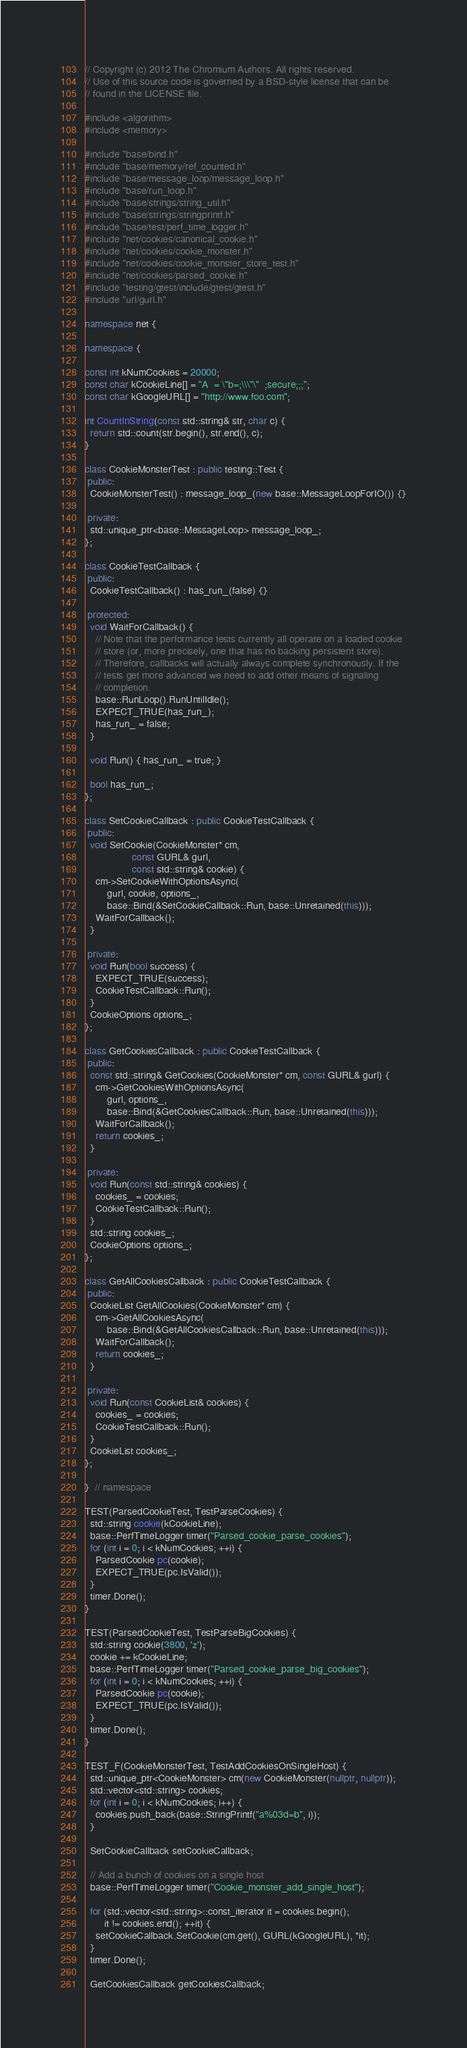Convert code to text. <code><loc_0><loc_0><loc_500><loc_500><_C++_>// Copyright (c) 2012 The Chromium Authors. All rights reserved.
// Use of this source code is governed by a BSD-style license that can be
// found in the LICENSE file.

#include <algorithm>
#include <memory>

#include "base/bind.h"
#include "base/memory/ref_counted.h"
#include "base/message_loop/message_loop.h"
#include "base/run_loop.h"
#include "base/strings/string_util.h"
#include "base/strings/stringprintf.h"
#include "base/test/perf_time_logger.h"
#include "net/cookies/canonical_cookie.h"
#include "net/cookies/cookie_monster.h"
#include "net/cookies/cookie_monster_store_test.h"
#include "net/cookies/parsed_cookie.h"
#include "testing/gtest/include/gtest/gtest.h"
#include "url/gurl.h"

namespace net {

namespace {

const int kNumCookies = 20000;
const char kCookieLine[] = "A  = \"b=;\\\"\"  ;secure;;;";
const char kGoogleURL[] = "http://www.foo.com";

int CountInString(const std::string& str, char c) {
  return std::count(str.begin(), str.end(), c);
}

class CookieMonsterTest : public testing::Test {
 public:
  CookieMonsterTest() : message_loop_(new base::MessageLoopForIO()) {}

 private:
  std::unique_ptr<base::MessageLoop> message_loop_;
};

class CookieTestCallback {
 public:
  CookieTestCallback() : has_run_(false) {}

 protected:
  void WaitForCallback() {
    // Note that the performance tests currently all operate on a loaded cookie
    // store (or, more precisely, one that has no backing persistent store).
    // Therefore, callbacks will actually always complete synchronously. If the
    // tests get more advanced we need to add other means of signaling
    // completion.
    base::RunLoop().RunUntilIdle();
    EXPECT_TRUE(has_run_);
    has_run_ = false;
  }

  void Run() { has_run_ = true; }

  bool has_run_;
};

class SetCookieCallback : public CookieTestCallback {
 public:
  void SetCookie(CookieMonster* cm,
                 const GURL& gurl,
                 const std::string& cookie) {
    cm->SetCookieWithOptionsAsync(
        gurl, cookie, options_,
        base::Bind(&SetCookieCallback::Run, base::Unretained(this)));
    WaitForCallback();
  }

 private:
  void Run(bool success) {
    EXPECT_TRUE(success);
    CookieTestCallback::Run();
  }
  CookieOptions options_;
};

class GetCookiesCallback : public CookieTestCallback {
 public:
  const std::string& GetCookies(CookieMonster* cm, const GURL& gurl) {
    cm->GetCookiesWithOptionsAsync(
        gurl, options_,
        base::Bind(&GetCookiesCallback::Run, base::Unretained(this)));
    WaitForCallback();
    return cookies_;
  }

 private:
  void Run(const std::string& cookies) {
    cookies_ = cookies;
    CookieTestCallback::Run();
  }
  std::string cookies_;
  CookieOptions options_;
};

class GetAllCookiesCallback : public CookieTestCallback {
 public:
  CookieList GetAllCookies(CookieMonster* cm) {
    cm->GetAllCookiesAsync(
        base::Bind(&GetAllCookiesCallback::Run, base::Unretained(this)));
    WaitForCallback();
    return cookies_;
  }

 private:
  void Run(const CookieList& cookies) {
    cookies_ = cookies;
    CookieTestCallback::Run();
  }
  CookieList cookies_;
};

}  // namespace

TEST(ParsedCookieTest, TestParseCookies) {
  std::string cookie(kCookieLine);
  base::PerfTimeLogger timer("Parsed_cookie_parse_cookies");
  for (int i = 0; i < kNumCookies; ++i) {
    ParsedCookie pc(cookie);
    EXPECT_TRUE(pc.IsValid());
  }
  timer.Done();
}

TEST(ParsedCookieTest, TestParseBigCookies) {
  std::string cookie(3800, 'z');
  cookie += kCookieLine;
  base::PerfTimeLogger timer("Parsed_cookie_parse_big_cookies");
  for (int i = 0; i < kNumCookies; ++i) {
    ParsedCookie pc(cookie);
    EXPECT_TRUE(pc.IsValid());
  }
  timer.Done();
}

TEST_F(CookieMonsterTest, TestAddCookiesOnSingleHost) {
  std::unique_ptr<CookieMonster> cm(new CookieMonster(nullptr, nullptr));
  std::vector<std::string> cookies;
  for (int i = 0; i < kNumCookies; i++) {
    cookies.push_back(base::StringPrintf("a%03d=b", i));
  }

  SetCookieCallback setCookieCallback;

  // Add a bunch of cookies on a single host
  base::PerfTimeLogger timer("Cookie_monster_add_single_host");

  for (std::vector<std::string>::const_iterator it = cookies.begin();
       it != cookies.end(); ++it) {
    setCookieCallback.SetCookie(cm.get(), GURL(kGoogleURL), *it);
  }
  timer.Done();

  GetCookiesCallback getCookiesCallback;
</code> 